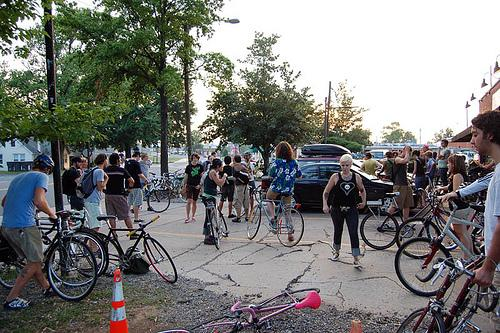Where would you normally find the orange and white thing in the foreground? Please explain your reasoning. road. Traffic cones are on the road. 